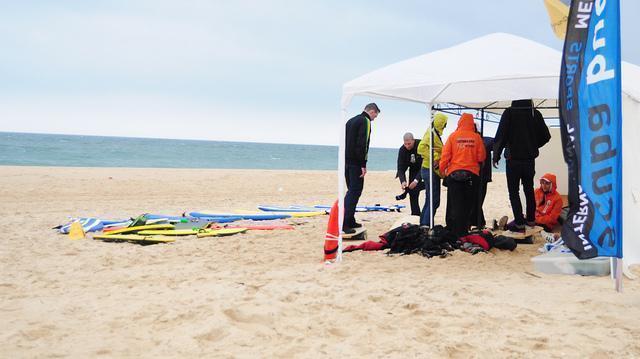What are they doing under the canopy?
Pick the right solution, then justify: 'Answer: answer
Rationale: rationale.'
Options: Fighting, resting, changing clothes, eating. Answer: changing clothes.
Rationale: The people change. 